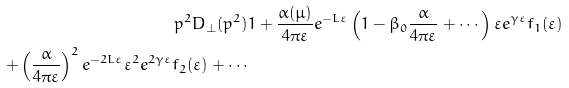<formula> <loc_0><loc_0><loc_500><loc_500>p ^ { 2 } D _ { \bot } ( p ^ { 2 } ) & 1 + \frac { \alpha ( \mu ) } { 4 \pi \varepsilon } e ^ { - L \varepsilon } \left ( 1 - \beta _ { 0 } \frac { \alpha } { 4 \pi \varepsilon } + \cdots \right ) \varepsilon e ^ { \gamma \varepsilon } f _ { 1 } ( \varepsilon ) \\ + \left ( \frac { \alpha } { 4 \pi \varepsilon } \right ) ^ { 2 } e ^ { - 2 L \varepsilon } \varepsilon ^ { 2 } e ^ { 2 \gamma \varepsilon } f _ { 2 } ( \varepsilon ) + \cdots</formula> 